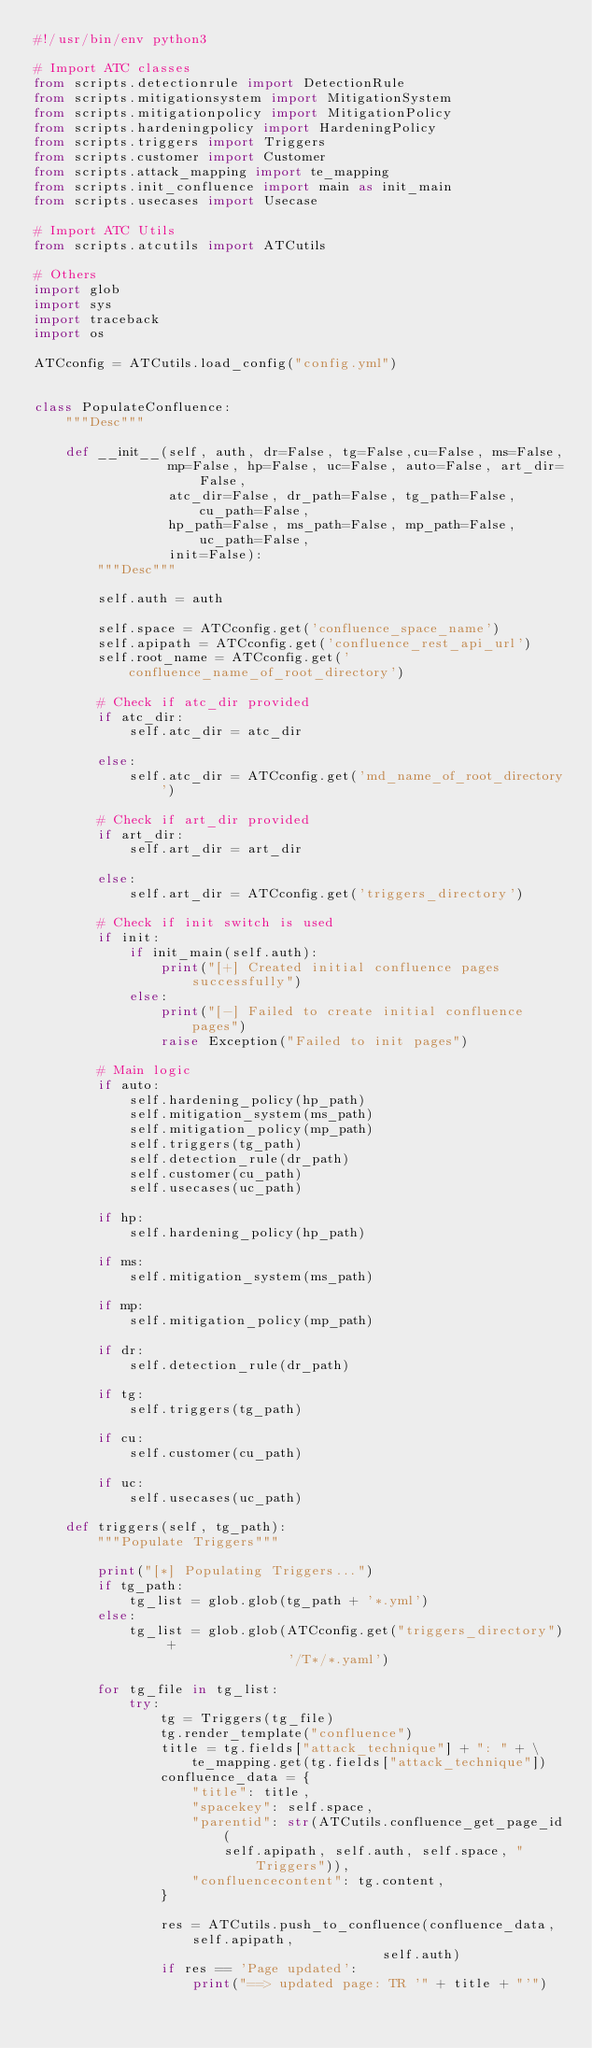<code> <loc_0><loc_0><loc_500><loc_500><_Python_>#!/usr/bin/env python3

# Import ATC classes
from scripts.detectionrule import DetectionRule
from scripts.mitigationsystem import MitigationSystem
from scripts.mitigationpolicy import MitigationPolicy
from scripts.hardeningpolicy import HardeningPolicy
from scripts.triggers import Triggers
from scripts.customer import Customer
from scripts.attack_mapping import te_mapping
from scripts.init_confluence import main as init_main
from scripts.usecases import Usecase

# Import ATC Utils
from scripts.atcutils import ATCutils

# Others
import glob
import sys
import traceback
import os

ATCconfig = ATCutils.load_config("config.yml")


class PopulateConfluence:
    """Desc"""

    def __init__(self, auth, dr=False, tg=False,cu=False, ms=False, 
                 mp=False, hp=False, uc=False, auto=False, art_dir=False, 
                 atc_dir=False, dr_path=False, tg_path=False, cu_path=False, 
                 hp_path=False, ms_path=False, mp_path=False, uc_path=False,
                 init=False):
        """Desc"""

        self.auth = auth

        self.space = ATCconfig.get('confluence_space_name')
        self.apipath = ATCconfig.get('confluence_rest_api_url')
        self.root_name = ATCconfig.get('confluence_name_of_root_directory')

        # Check if atc_dir provided
        if atc_dir:
            self.atc_dir = atc_dir

        else:
            self.atc_dir = ATCconfig.get('md_name_of_root_directory')

        # Check if art_dir provided
        if art_dir:
            self.art_dir = art_dir

        else:
            self.art_dir = ATCconfig.get('triggers_directory')

        # Check if init switch is used
        if init:
            if init_main(self.auth):
                print("[+] Created initial confluence pages successfully")
            else:
                print("[-] Failed to create initial confluence pages")
                raise Exception("Failed to init pages")

        # Main logic
        if auto:
            self.hardening_policy(hp_path)
            self.mitigation_system(ms_path)
            self.mitigation_policy(mp_path)
            self.triggers(tg_path)
            self.detection_rule(dr_path)
            self.customer(cu_path)
            self.usecases(uc_path)

        if hp:
            self.hardening_policy(hp_path)

        if ms:
            self.mitigation_system(ms_path)

        if mp:
            self.mitigation_policy(mp_path)

        if dr:
            self.detection_rule(dr_path)

        if tg:
            self.triggers(tg_path)

        if cu:
            self.customer(cu_path)

        if uc:
            self.usecases(uc_path)

    def triggers(self, tg_path):
        """Populate Triggers"""

        print("[*] Populating Triggers...")
        if tg_path:
            tg_list = glob.glob(tg_path + '*.yml')
        else:
            tg_list = glob.glob(ATCconfig.get("triggers_directory") +
                                '/T*/*.yaml')

        for tg_file in tg_list:
            try:
                tg = Triggers(tg_file)
                tg.render_template("confluence")
                title = tg.fields["attack_technique"] + ": " + \
                    te_mapping.get(tg.fields["attack_technique"])
                confluence_data = {
                    "title": title,
                    "spacekey": self.space,
                    "parentid": str(ATCutils.confluence_get_page_id(
                        self.apipath, self.auth, self.space, "Triggers")),
                    "confluencecontent": tg.content,
                }

                res = ATCutils.push_to_confluence(confluence_data, self.apipath,
                                            self.auth)
                if res == 'Page updated':
            	    print("==> updated page: TR '" + title + "'")</code> 